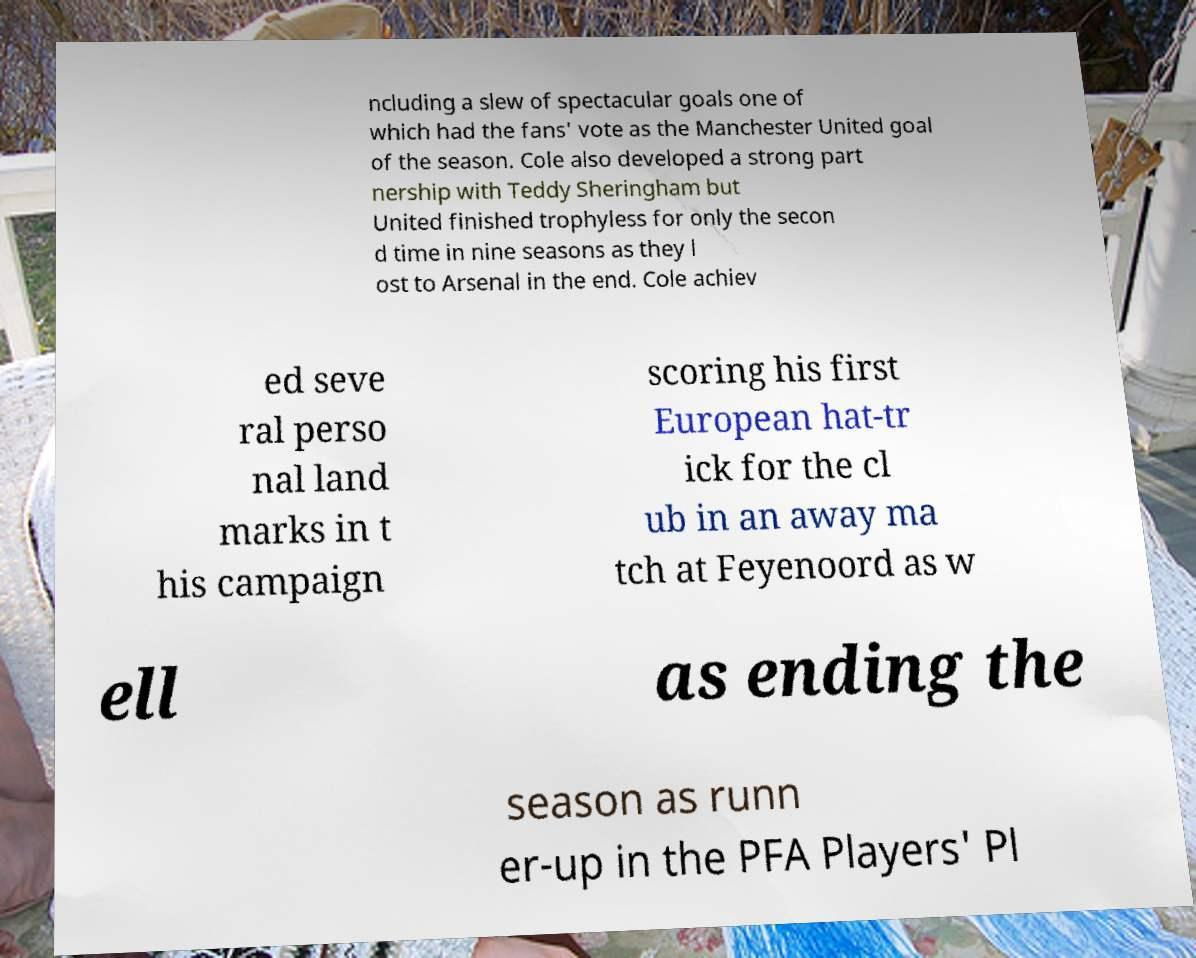For documentation purposes, I need the text within this image transcribed. Could you provide that? ncluding a slew of spectacular goals one of which had the fans' vote as the Manchester United goal of the season. Cole also developed a strong part nership with Teddy Sheringham but United finished trophyless for only the secon d time in nine seasons as they l ost to Arsenal in the end. Cole achiev ed seve ral perso nal land marks in t his campaign scoring his first European hat-tr ick for the cl ub in an away ma tch at Feyenoord as w ell as ending the season as runn er-up in the PFA Players' Pl 